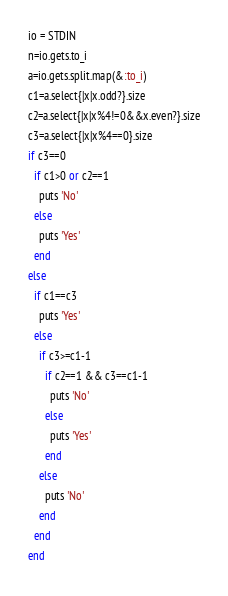Convert code to text. <code><loc_0><loc_0><loc_500><loc_500><_Ruby_>io = STDIN
n=io.gets.to_i
a=io.gets.split.map(&:to_i)
c1=a.select{|x|x.odd?}.size
c2=a.select{|x|x%4!=0&&x.even?}.size
c3=a.select{|x|x%4==0}.size
if c3==0
  if c1>0 or c2==1
    puts 'No'
  else
    puts 'Yes'
  end
else
  if c1==c3
    puts 'Yes'
  else
    if c3>=c1-1
      if c2==1 && c3==c1-1
        puts 'No'
      else
        puts 'Yes'
      end
    else
      puts 'No'
    end
  end
end
</code> 